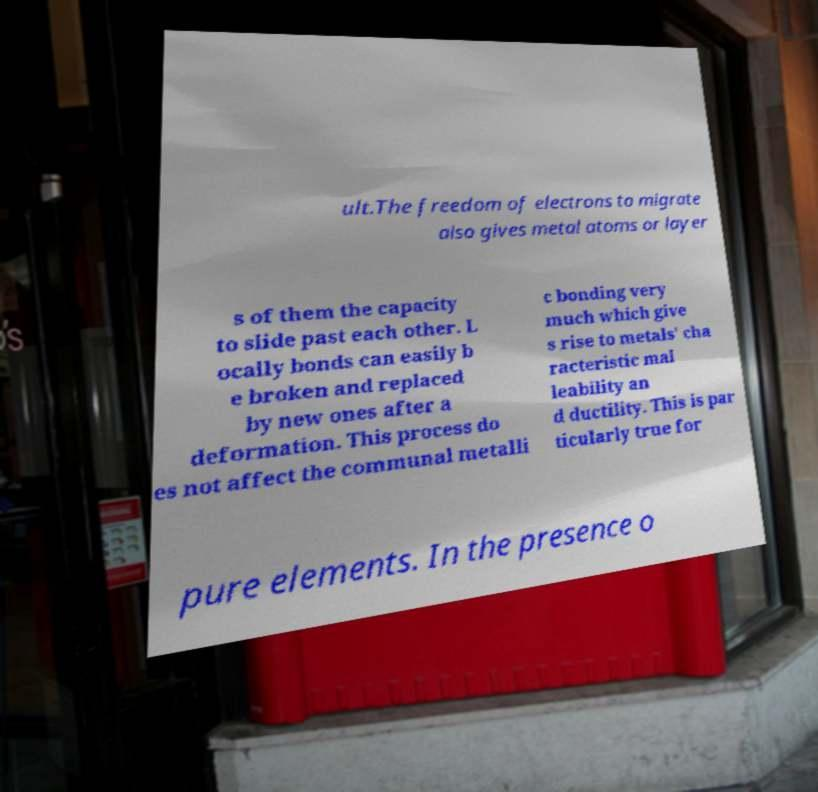Please read and relay the text visible in this image. What does it say? ult.The freedom of electrons to migrate also gives metal atoms or layer s of them the capacity to slide past each other. L ocally bonds can easily b e broken and replaced by new ones after a deformation. This process do es not affect the communal metalli c bonding very much which give s rise to metals' cha racteristic mal leability an d ductility. This is par ticularly true for pure elements. In the presence o 